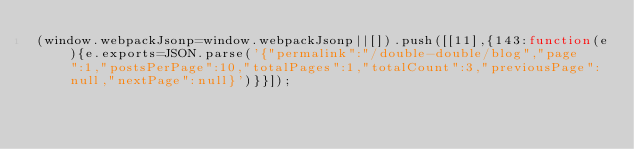<code> <loc_0><loc_0><loc_500><loc_500><_JavaScript_>(window.webpackJsonp=window.webpackJsonp||[]).push([[11],{143:function(e){e.exports=JSON.parse('{"permalink":"/double-double/blog","page":1,"postsPerPage":10,"totalPages":1,"totalCount":3,"previousPage":null,"nextPage":null}')}}]);</code> 